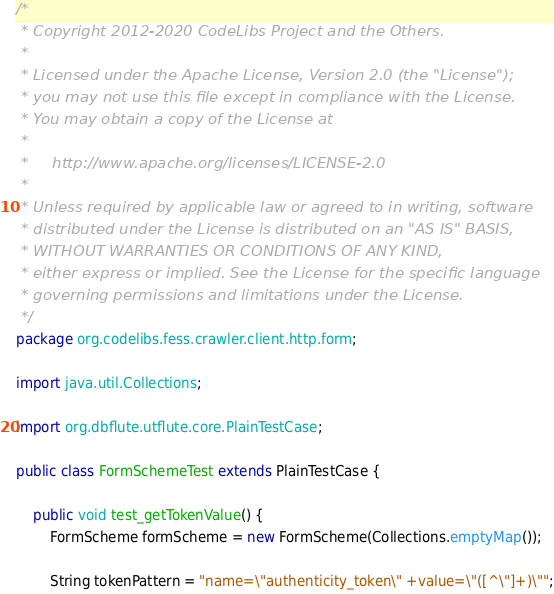Convert code to text. <code><loc_0><loc_0><loc_500><loc_500><_Java_>/*
 * Copyright 2012-2020 CodeLibs Project and the Others.
 *
 * Licensed under the Apache License, Version 2.0 (the "License");
 * you may not use this file except in compliance with the License.
 * You may obtain a copy of the License at
 *
 *     http://www.apache.org/licenses/LICENSE-2.0
 *
 * Unless required by applicable law or agreed to in writing, software
 * distributed under the License is distributed on an "AS IS" BASIS,
 * WITHOUT WARRANTIES OR CONDITIONS OF ANY KIND,
 * either express or implied. See the License for the specific language
 * governing permissions and limitations under the License.
 */
package org.codelibs.fess.crawler.client.http.form;

import java.util.Collections;

import org.dbflute.utflute.core.PlainTestCase;

public class FormSchemeTest extends PlainTestCase {

    public void test_getTokenValue() {
        FormScheme formScheme = new FormScheme(Collections.emptyMap());

        String tokenPattern = "name=\"authenticity_token\" +value=\"([^\"]+)\"";</code> 